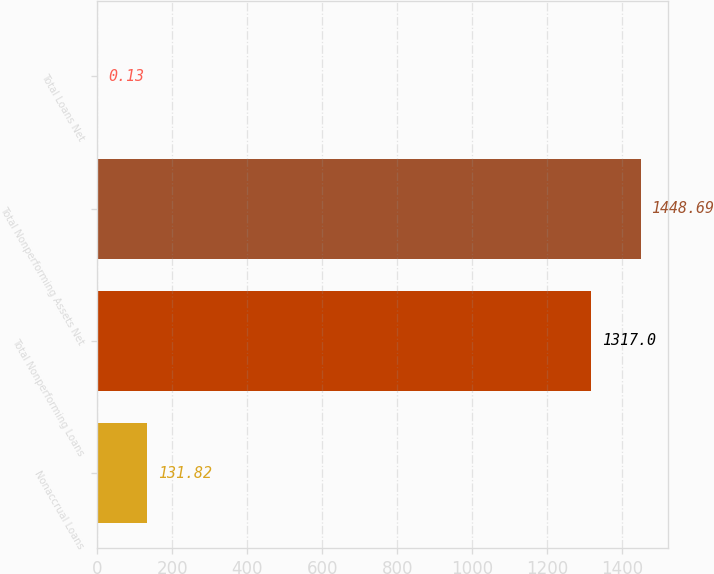Convert chart to OTSL. <chart><loc_0><loc_0><loc_500><loc_500><bar_chart><fcel>Nonaccrual Loans<fcel>Total Nonperforming Loans<fcel>Total Nonperforming Assets Net<fcel>Total Loans Net<nl><fcel>131.82<fcel>1317<fcel>1448.69<fcel>0.13<nl></chart> 